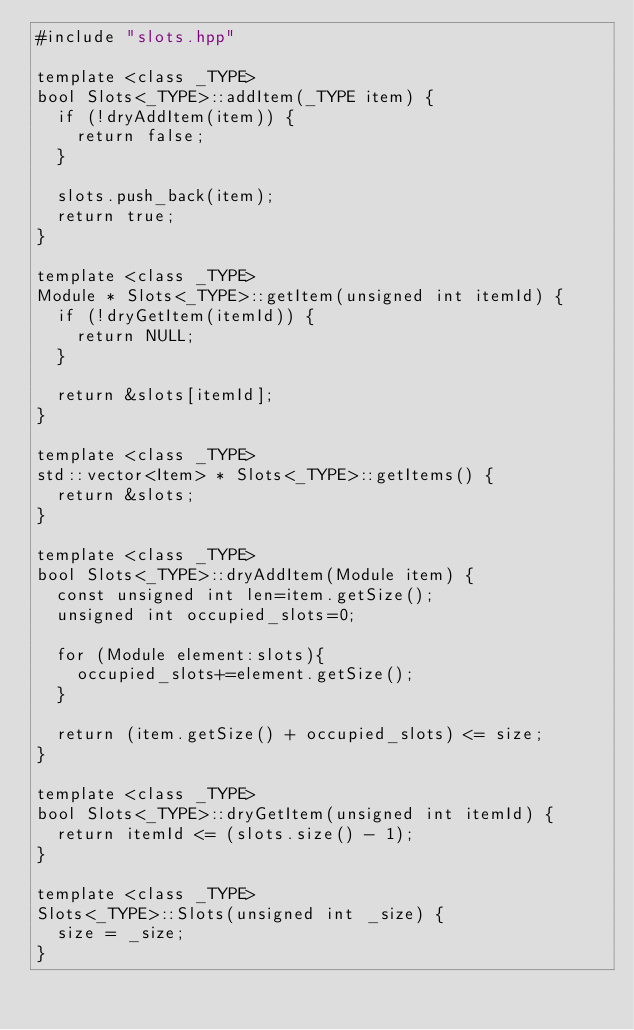<code> <loc_0><loc_0><loc_500><loc_500><_C++_>#include "slots.hpp"

template <class _TYPE>
bool Slots<_TYPE>::addItem(_TYPE item) {
  if (!dryAddItem(item)) {
    return false;
  }

  slots.push_back(item);
  return true;
}

template <class _TYPE>
Module * Slots<_TYPE>::getItem(unsigned int itemId) {
  if (!dryGetItem(itemId)) {
    return NULL;
  }

  return &slots[itemId];
}

template <class _TYPE>
std::vector<Item> * Slots<_TYPE>::getItems() {
  return &slots;
}

template <class _TYPE>
bool Slots<_TYPE>::dryAddItem(Module item) {
  const unsigned int len=item.getSize();
  unsigned int occupied_slots=0;

  for (Module element:slots){
    occupied_slots+=element.getSize();
  }

  return (item.getSize() + occupied_slots) <= size;
}

template <class _TYPE>
bool Slots<_TYPE>::dryGetItem(unsigned int itemId) {
  return itemId <= (slots.size() - 1);
}

template <class _TYPE>
Slots<_TYPE>::Slots(unsigned int _size) {
  size = _size;
}
</code> 